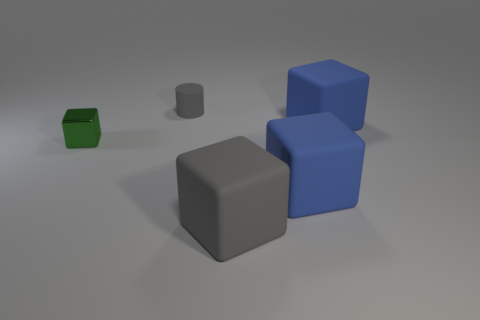Subtract all large blocks. How many blocks are left? 1 Add 2 large green rubber blocks. How many objects exist? 7 Subtract all red cubes. Subtract all blue balls. How many cubes are left? 4 Subtract all cylinders. How many objects are left? 4 Subtract all big blocks. Subtract all small green metal things. How many objects are left? 1 Add 1 shiny blocks. How many shiny blocks are left? 2 Add 5 brown matte cylinders. How many brown matte cylinders exist? 5 Subtract 0 brown cylinders. How many objects are left? 5 